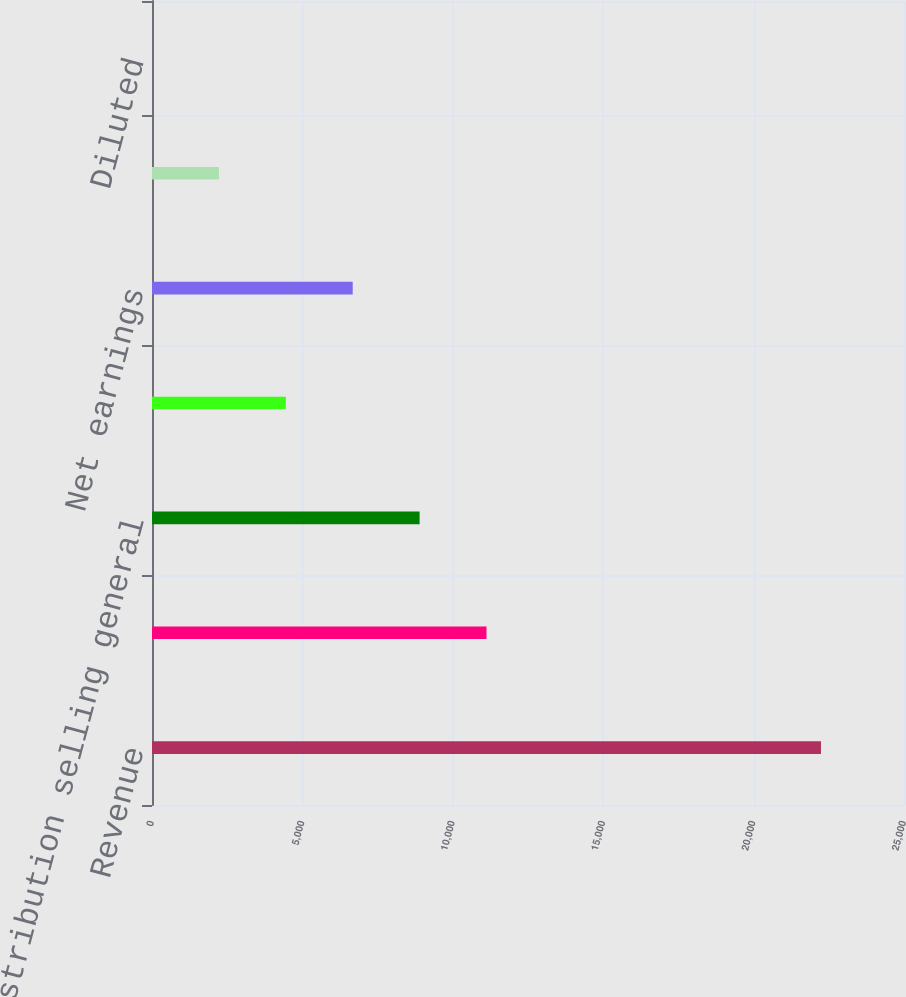Convert chart. <chart><loc_0><loc_0><loc_500><loc_500><bar_chart><fcel>Revenue<fcel>Gross margin<fcel>Distribution selling general<fcel>Earnings from continuing<fcel>Net earnings<fcel>Basic<fcel>Diluted<nl><fcel>22240<fcel>11120.4<fcel>8896.47<fcel>4448.63<fcel>6672.55<fcel>2224.71<fcel>0.79<nl></chart> 